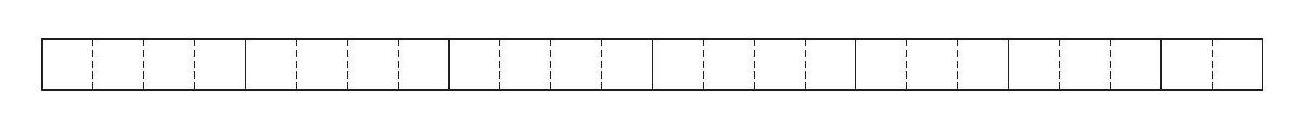Can we use all the smaller rectangles to form a square instead of a rectangle? A square requires all sides to be the same length, but with the given rectangle pieces, we cannot create a perfect square, since their combined length is 26 meters, which is not a perfect square number. Hence, we have to settle with a rectangle for the smallest perimeter. 